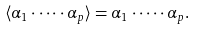<formula> <loc_0><loc_0><loc_500><loc_500>\langle \alpha _ { 1 } \cdot \dots \cdot \alpha _ { p } \rangle = \alpha _ { 1 } \cdot \dots \cdot \alpha _ { p } .</formula> 